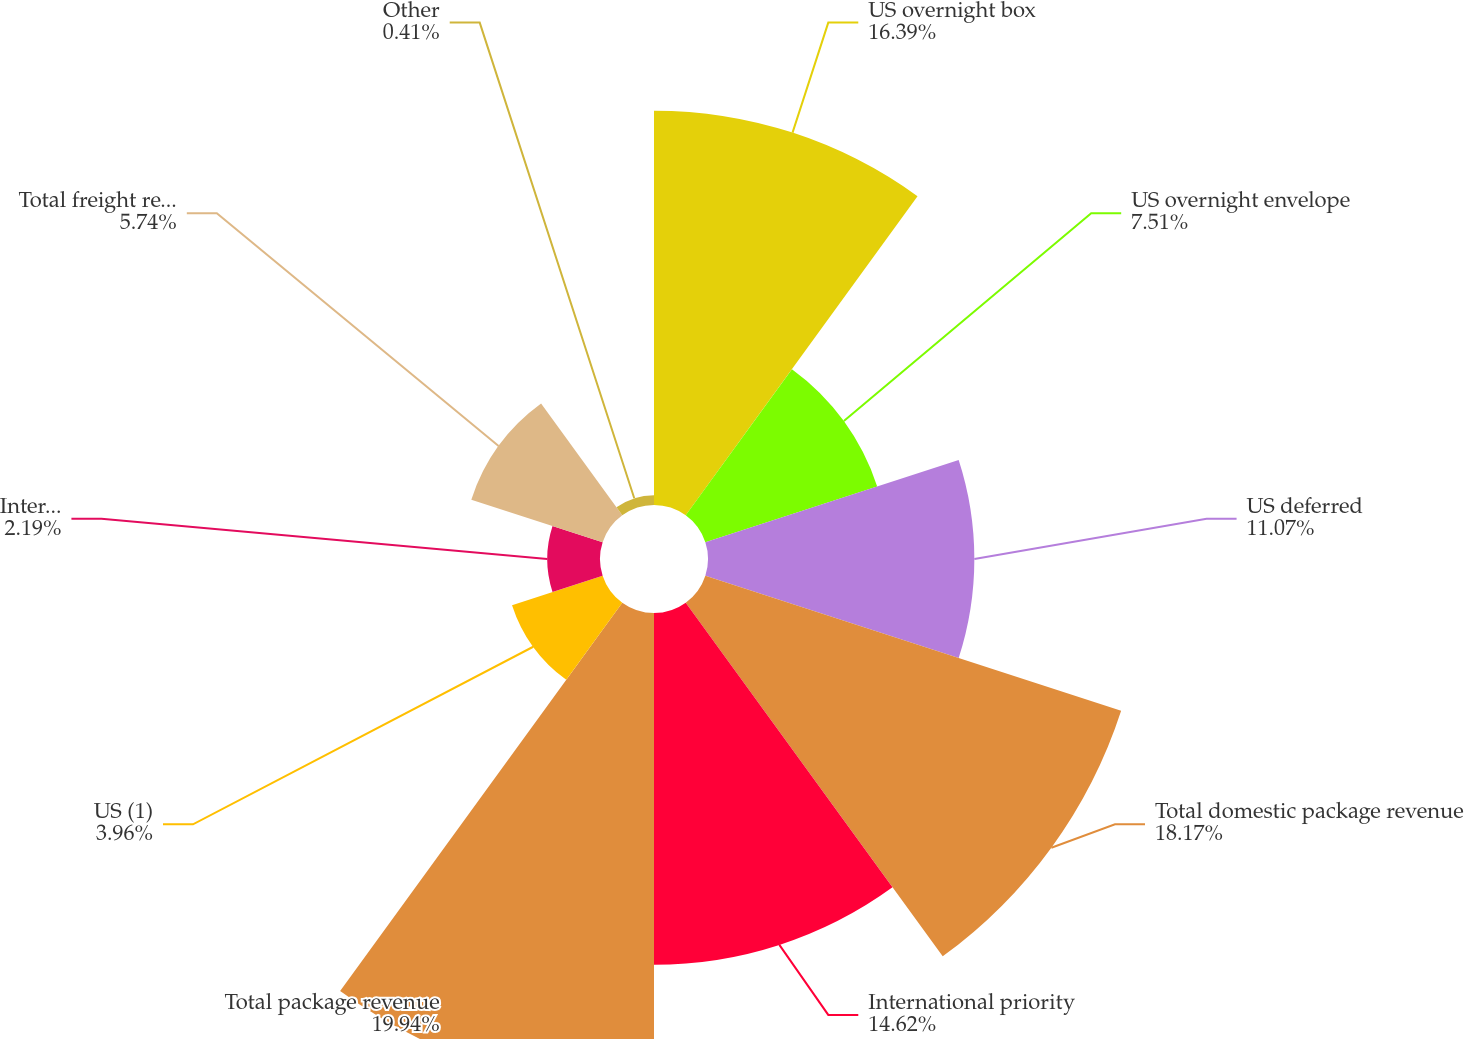<chart> <loc_0><loc_0><loc_500><loc_500><pie_chart><fcel>US overnight box<fcel>US overnight envelope<fcel>US deferred<fcel>Total domestic package revenue<fcel>International priority<fcel>Total package revenue<fcel>US (1)<fcel>International<fcel>Total freight revenue<fcel>Other<nl><fcel>16.39%<fcel>7.51%<fcel>11.07%<fcel>18.17%<fcel>14.62%<fcel>19.95%<fcel>3.96%<fcel>2.19%<fcel>5.74%<fcel>0.41%<nl></chart> 